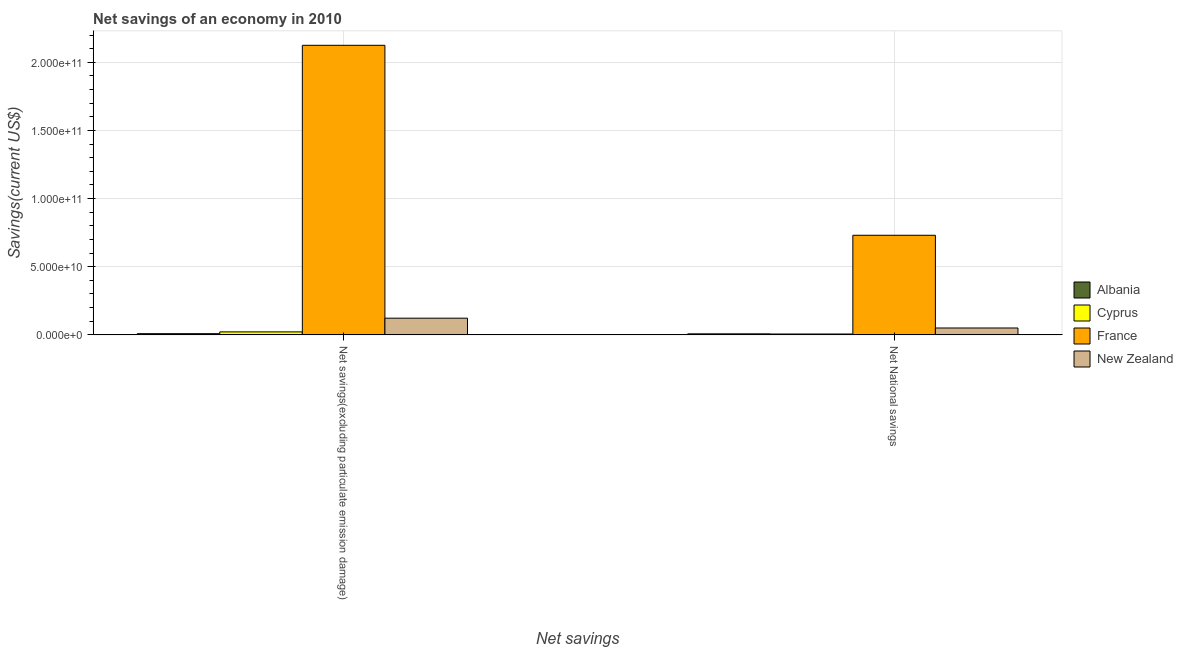How many different coloured bars are there?
Provide a short and direct response. 4. Are the number of bars per tick equal to the number of legend labels?
Provide a succinct answer. Yes. Are the number of bars on each tick of the X-axis equal?
Your answer should be compact. Yes. How many bars are there on the 1st tick from the left?
Keep it short and to the point. 4. What is the label of the 2nd group of bars from the left?
Give a very brief answer. Net National savings. What is the net savings(excluding particulate emission damage) in Cyprus?
Keep it short and to the point. 2.20e+09. Across all countries, what is the maximum net national savings?
Provide a short and direct response. 7.31e+1. Across all countries, what is the minimum net savings(excluding particulate emission damage)?
Give a very brief answer. 8.83e+08. In which country was the net national savings minimum?
Your answer should be compact. Cyprus. What is the total net national savings in the graph?
Your response must be concise. 7.96e+1. What is the difference between the net national savings in Cyprus and that in New Zealand?
Keep it short and to the point. -4.42e+09. What is the difference between the net national savings in New Zealand and the net savings(excluding particulate emission damage) in France?
Give a very brief answer. -2.07e+11. What is the average net savings(excluding particulate emission damage) per country?
Keep it short and to the point. 5.70e+1. What is the difference between the net national savings and net savings(excluding particulate emission damage) in Cyprus?
Your answer should be compact. -1.55e+09. What is the ratio of the net savings(excluding particulate emission damage) in France to that in New Zealand?
Provide a short and direct response. 17.33. In how many countries, is the net savings(excluding particulate emission damage) greater than the average net savings(excluding particulate emission damage) taken over all countries?
Your answer should be compact. 1. What does the 3rd bar from the left in Net National savings represents?
Keep it short and to the point. France. Does the graph contain any zero values?
Provide a short and direct response. No. Does the graph contain grids?
Give a very brief answer. Yes. Where does the legend appear in the graph?
Give a very brief answer. Center right. How many legend labels are there?
Your answer should be very brief. 4. What is the title of the graph?
Your answer should be very brief. Net savings of an economy in 2010. Does "Andorra" appear as one of the legend labels in the graph?
Ensure brevity in your answer.  No. What is the label or title of the X-axis?
Your answer should be very brief. Net savings. What is the label or title of the Y-axis?
Your response must be concise. Savings(current US$). What is the Savings(current US$) of Albania in Net savings(excluding particulate emission damage)?
Keep it short and to the point. 8.83e+08. What is the Savings(current US$) in Cyprus in Net savings(excluding particulate emission damage)?
Make the answer very short. 2.20e+09. What is the Savings(current US$) in France in Net savings(excluding particulate emission damage)?
Provide a succinct answer. 2.12e+11. What is the Savings(current US$) of New Zealand in Net savings(excluding particulate emission damage)?
Provide a short and direct response. 1.23e+1. What is the Savings(current US$) in Albania in Net National savings?
Offer a terse response. 7.64e+08. What is the Savings(current US$) of Cyprus in Net National savings?
Make the answer very short. 6.46e+08. What is the Savings(current US$) in France in Net National savings?
Provide a succinct answer. 7.31e+1. What is the Savings(current US$) of New Zealand in Net National savings?
Make the answer very short. 5.06e+09. Across all Net savings, what is the maximum Savings(current US$) of Albania?
Keep it short and to the point. 8.83e+08. Across all Net savings, what is the maximum Savings(current US$) of Cyprus?
Provide a succinct answer. 2.20e+09. Across all Net savings, what is the maximum Savings(current US$) of France?
Your answer should be compact. 2.12e+11. Across all Net savings, what is the maximum Savings(current US$) in New Zealand?
Your answer should be very brief. 1.23e+1. Across all Net savings, what is the minimum Savings(current US$) in Albania?
Offer a terse response. 7.64e+08. Across all Net savings, what is the minimum Savings(current US$) in Cyprus?
Offer a very short reply. 6.46e+08. Across all Net savings, what is the minimum Savings(current US$) in France?
Give a very brief answer. 7.31e+1. Across all Net savings, what is the minimum Savings(current US$) in New Zealand?
Offer a terse response. 5.06e+09. What is the total Savings(current US$) in Albania in the graph?
Offer a very short reply. 1.65e+09. What is the total Savings(current US$) in Cyprus in the graph?
Keep it short and to the point. 2.85e+09. What is the total Savings(current US$) of France in the graph?
Provide a short and direct response. 2.86e+11. What is the total Savings(current US$) in New Zealand in the graph?
Offer a very short reply. 1.73e+1. What is the difference between the Savings(current US$) in Albania in Net savings(excluding particulate emission damage) and that in Net National savings?
Provide a short and direct response. 1.18e+08. What is the difference between the Savings(current US$) in Cyprus in Net savings(excluding particulate emission damage) and that in Net National savings?
Your answer should be compact. 1.55e+09. What is the difference between the Savings(current US$) in France in Net savings(excluding particulate emission damage) and that in Net National savings?
Give a very brief answer. 1.39e+11. What is the difference between the Savings(current US$) of New Zealand in Net savings(excluding particulate emission damage) and that in Net National savings?
Make the answer very short. 7.20e+09. What is the difference between the Savings(current US$) in Albania in Net savings(excluding particulate emission damage) and the Savings(current US$) in Cyprus in Net National savings?
Your answer should be very brief. 2.37e+08. What is the difference between the Savings(current US$) of Albania in Net savings(excluding particulate emission damage) and the Savings(current US$) of France in Net National savings?
Give a very brief answer. -7.22e+1. What is the difference between the Savings(current US$) of Albania in Net savings(excluding particulate emission damage) and the Savings(current US$) of New Zealand in Net National savings?
Your response must be concise. -4.18e+09. What is the difference between the Savings(current US$) of Cyprus in Net savings(excluding particulate emission damage) and the Savings(current US$) of France in Net National savings?
Ensure brevity in your answer.  -7.09e+1. What is the difference between the Savings(current US$) of Cyprus in Net savings(excluding particulate emission damage) and the Savings(current US$) of New Zealand in Net National savings?
Provide a succinct answer. -2.86e+09. What is the difference between the Savings(current US$) in France in Net savings(excluding particulate emission damage) and the Savings(current US$) in New Zealand in Net National savings?
Give a very brief answer. 2.07e+11. What is the average Savings(current US$) of Albania per Net savings?
Offer a very short reply. 8.24e+08. What is the average Savings(current US$) in Cyprus per Net savings?
Provide a succinct answer. 1.42e+09. What is the average Savings(current US$) of France per Net savings?
Give a very brief answer. 1.43e+11. What is the average Savings(current US$) of New Zealand per Net savings?
Ensure brevity in your answer.  8.66e+09. What is the difference between the Savings(current US$) in Albania and Savings(current US$) in Cyprus in Net savings(excluding particulate emission damage)?
Keep it short and to the point. -1.32e+09. What is the difference between the Savings(current US$) of Albania and Savings(current US$) of France in Net savings(excluding particulate emission damage)?
Provide a short and direct response. -2.12e+11. What is the difference between the Savings(current US$) in Albania and Savings(current US$) in New Zealand in Net savings(excluding particulate emission damage)?
Provide a short and direct response. -1.14e+1. What is the difference between the Savings(current US$) of Cyprus and Savings(current US$) of France in Net savings(excluding particulate emission damage)?
Give a very brief answer. -2.10e+11. What is the difference between the Savings(current US$) in Cyprus and Savings(current US$) in New Zealand in Net savings(excluding particulate emission damage)?
Your answer should be very brief. -1.01e+1. What is the difference between the Savings(current US$) in France and Savings(current US$) in New Zealand in Net savings(excluding particulate emission damage)?
Offer a terse response. 2.00e+11. What is the difference between the Savings(current US$) in Albania and Savings(current US$) in Cyprus in Net National savings?
Keep it short and to the point. 1.18e+08. What is the difference between the Savings(current US$) in Albania and Savings(current US$) in France in Net National savings?
Make the answer very short. -7.23e+1. What is the difference between the Savings(current US$) of Albania and Savings(current US$) of New Zealand in Net National savings?
Offer a terse response. -4.30e+09. What is the difference between the Savings(current US$) of Cyprus and Savings(current US$) of France in Net National savings?
Your answer should be compact. -7.24e+1. What is the difference between the Savings(current US$) of Cyprus and Savings(current US$) of New Zealand in Net National savings?
Provide a short and direct response. -4.42e+09. What is the difference between the Savings(current US$) of France and Savings(current US$) of New Zealand in Net National savings?
Offer a very short reply. 6.80e+1. What is the ratio of the Savings(current US$) in Albania in Net savings(excluding particulate emission damage) to that in Net National savings?
Provide a succinct answer. 1.15. What is the ratio of the Savings(current US$) of Cyprus in Net savings(excluding particulate emission damage) to that in Net National savings?
Offer a terse response. 3.41. What is the ratio of the Savings(current US$) in France in Net savings(excluding particulate emission damage) to that in Net National savings?
Your answer should be very brief. 2.91. What is the ratio of the Savings(current US$) of New Zealand in Net savings(excluding particulate emission damage) to that in Net National savings?
Your answer should be compact. 2.42. What is the difference between the highest and the second highest Savings(current US$) of Albania?
Keep it short and to the point. 1.18e+08. What is the difference between the highest and the second highest Savings(current US$) of Cyprus?
Your answer should be compact. 1.55e+09. What is the difference between the highest and the second highest Savings(current US$) of France?
Provide a short and direct response. 1.39e+11. What is the difference between the highest and the second highest Savings(current US$) of New Zealand?
Offer a terse response. 7.20e+09. What is the difference between the highest and the lowest Savings(current US$) of Albania?
Provide a short and direct response. 1.18e+08. What is the difference between the highest and the lowest Savings(current US$) in Cyprus?
Give a very brief answer. 1.55e+09. What is the difference between the highest and the lowest Savings(current US$) in France?
Keep it short and to the point. 1.39e+11. What is the difference between the highest and the lowest Savings(current US$) of New Zealand?
Keep it short and to the point. 7.20e+09. 